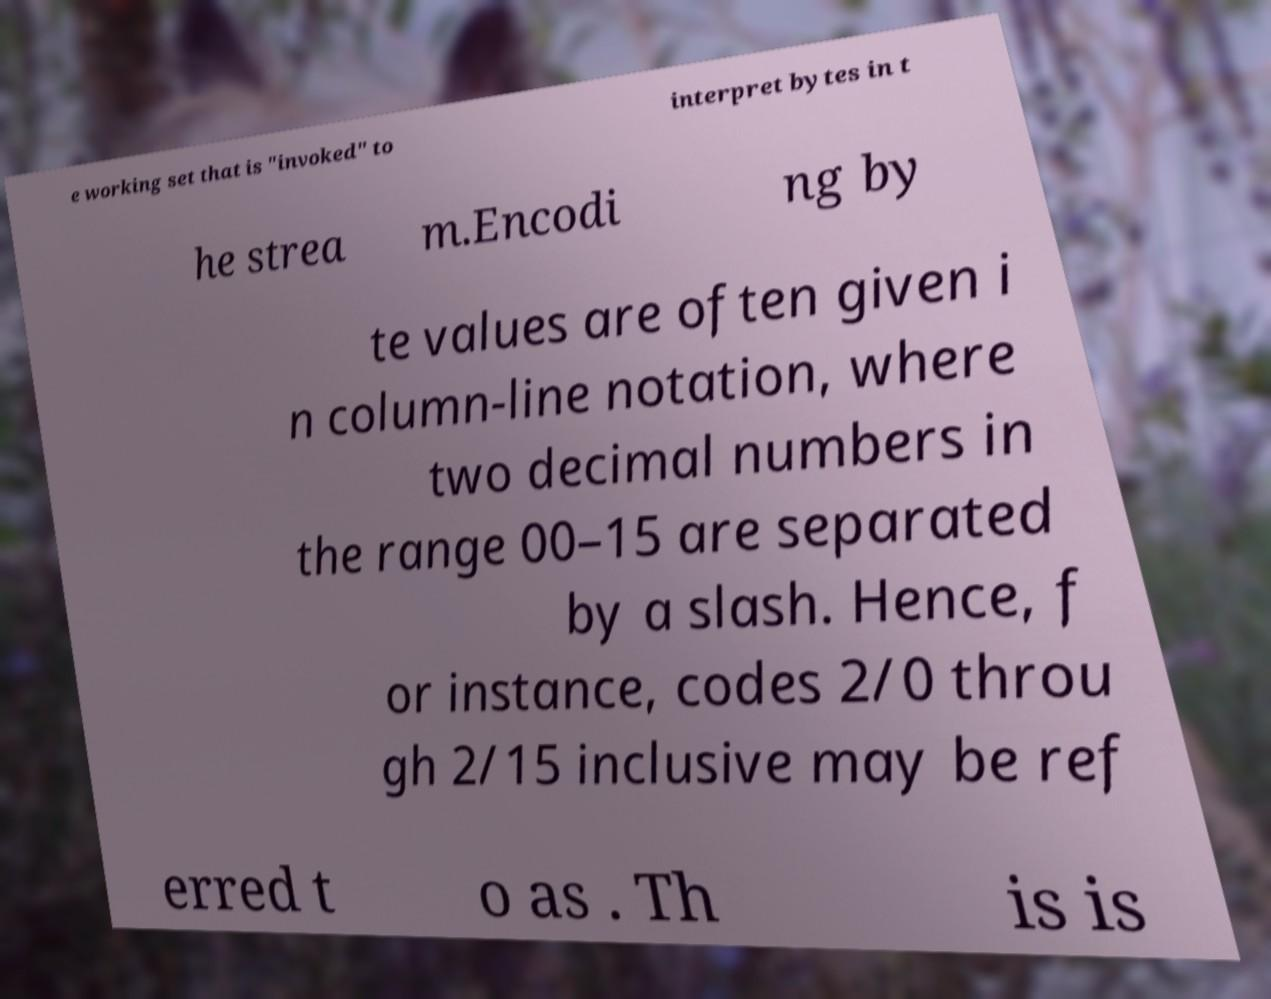For documentation purposes, I need the text within this image transcribed. Could you provide that? e working set that is "invoked" to interpret bytes in t he strea m.Encodi ng by te values are often given i n column-line notation, where two decimal numbers in the range 00–15 are separated by a slash. Hence, f or instance, codes 2/0 throu gh 2/15 inclusive may be ref erred t o as . Th is is 